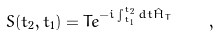<formula> <loc_0><loc_0><loc_500><loc_500>S ( t _ { 2 } , t _ { 1 } ) = T e ^ { - i \int _ { t _ { 1 } } ^ { t _ { 2 } } d t \hat { H } _ { T } } \quad ,</formula> 